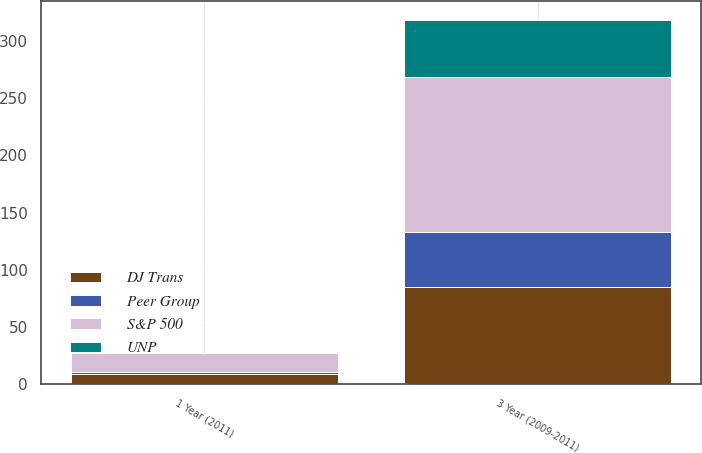<chart> <loc_0><loc_0><loc_500><loc_500><stacked_bar_chart><ecel><fcel>1 Year (2011)<fcel>3 Year (2009-2011)<nl><fcel>S&P 500<fcel>16.6<fcel>135.1<nl><fcel>DJ Trans<fcel>9<fcel>84.7<nl><fcel>UNP<fcel>0<fcel>50.3<nl><fcel>Peer Group<fcel>2.1<fcel>48.6<nl></chart> 